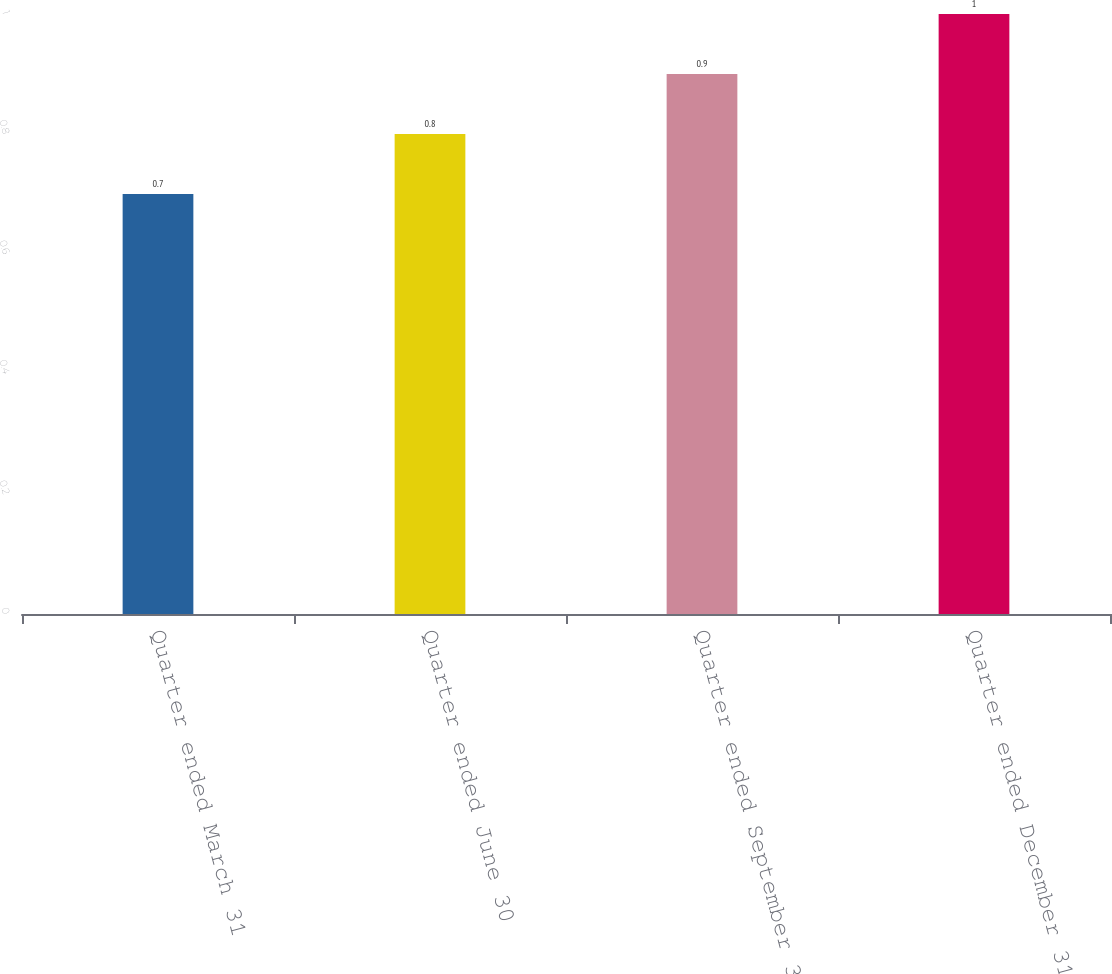Convert chart. <chart><loc_0><loc_0><loc_500><loc_500><bar_chart><fcel>Quarter ended March 31<fcel>Quarter ended June 30<fcel>Quarter ended September 30<fcel>Quarter ended December 31<nl><fcel>0.7<fcel>0.8<fcel>0.9<fcel>1<nl></chart> 